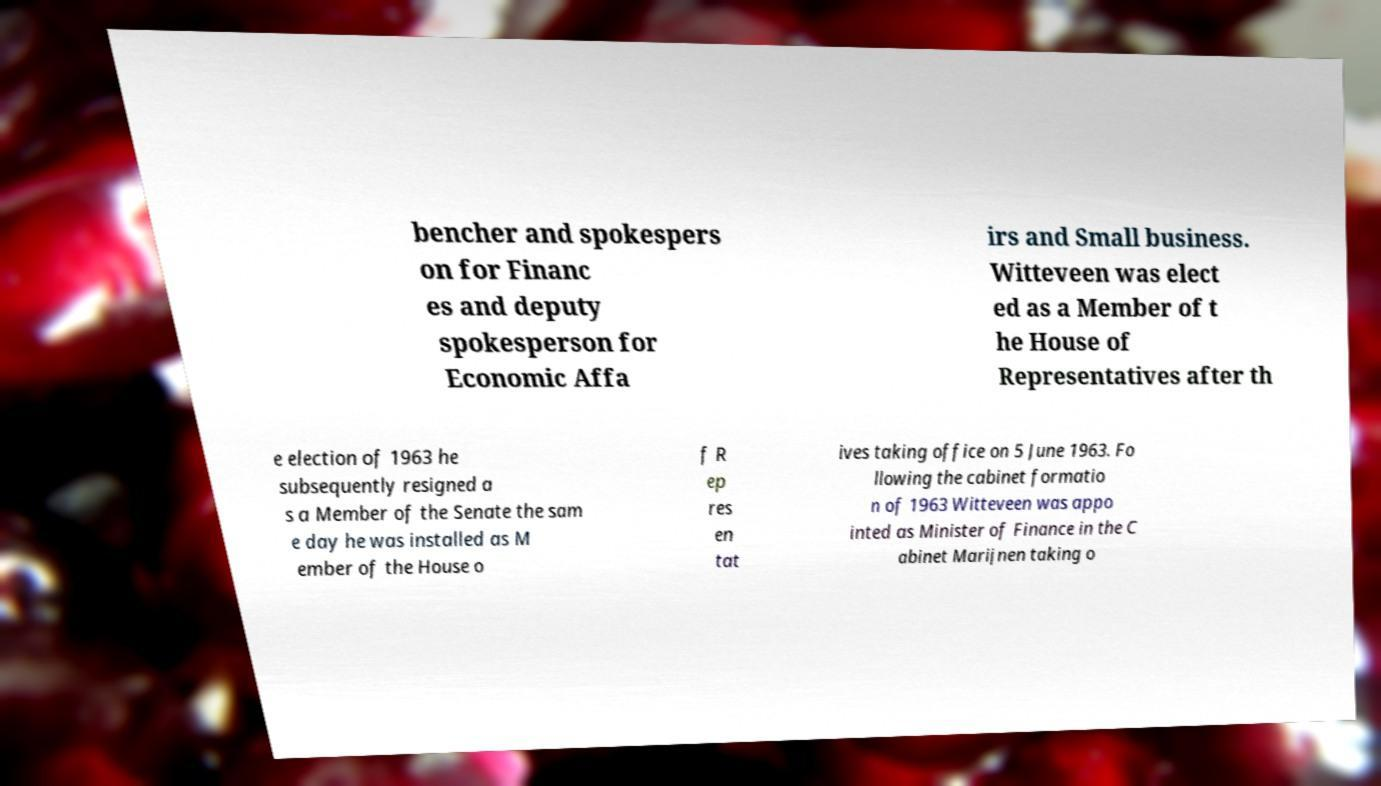Could you extract and type out the text from this image? bencher and spokespers on for Financ es and deputy spokesperson for Economic Affa irs and Small business. Witteveen was elect ed as a Member of t he House of Representatives after th e election of 1963 he subsequently resigned a s a Member of the Senate the sam e day he was installed as M ember of the House o f R ep res en tat ives taking office on 5 June 1963. Fo llowing the cabinet formatio n of 1963 Witteveen was appo inted as Minister of Finance in the C abinet Marijnen taking o 